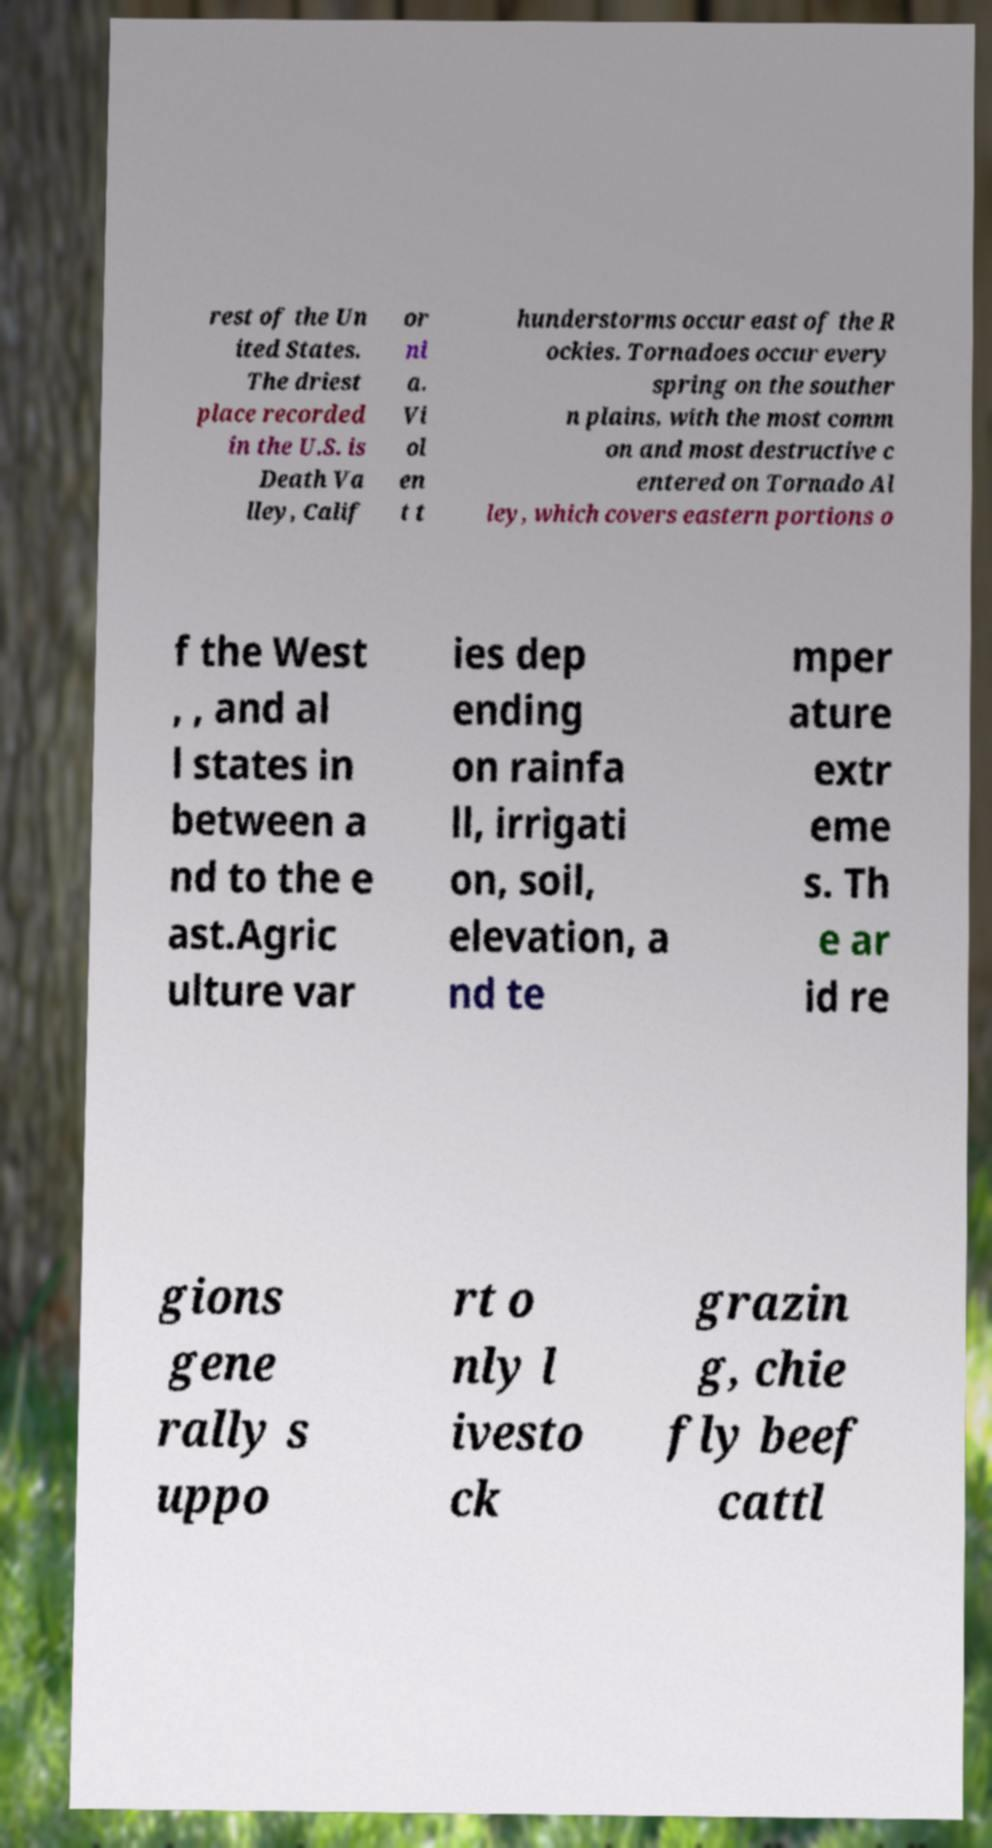What messages or text are displayed in this image? I need them in a readable, typed format. rest of the Un ited States. The driest place recorded in the U.S. is Death Va lley, Calif or ni a. Vi ol en t t hunderstorms occur east of the R ockies. Tornadoes occur every spring on the souther n plains, with the most comm on and most destructive c entered on Tornado Al ley, which covers eastern portions o f the West , , and al l states in between a nd to the e ast.Agric ulture var ies dep ending on rainfa ll, irrigati on, soil, elevation, a nd te mper ature extr eme s. Th e ar id re gions gene rally s uppo rt o nly l ivesto ck grazin g, chie fly beef cattl 